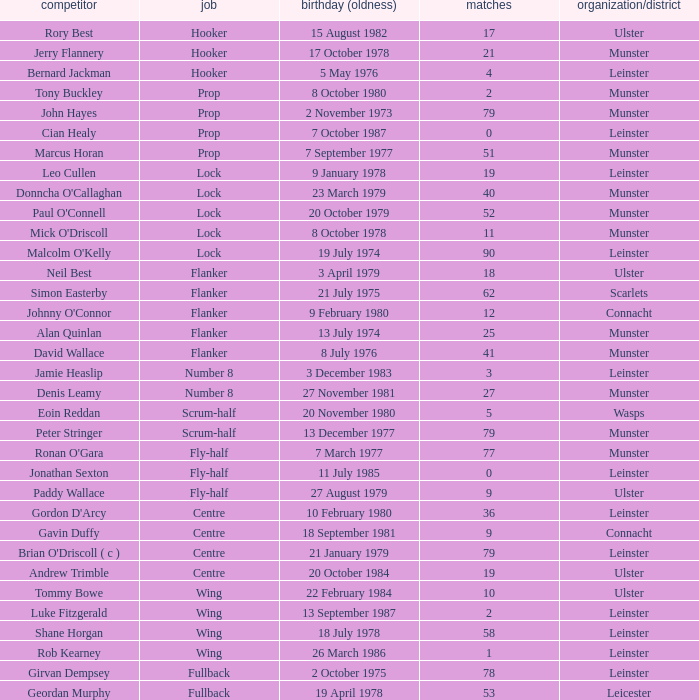What is the total of Caps when player born 13 December 1977? 79.0. 